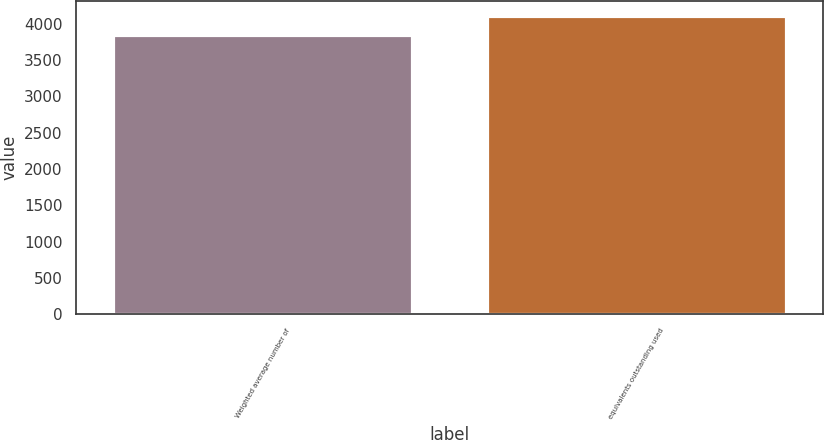Convert chart to OTSL. <chart><loc_0><loc_0><loc_500><loc_500><bar_chart><fcel>Weighted average number of<fcel>equivalents outstanding used<nl><fcel>3847<fcel>4104<nl></chart> 